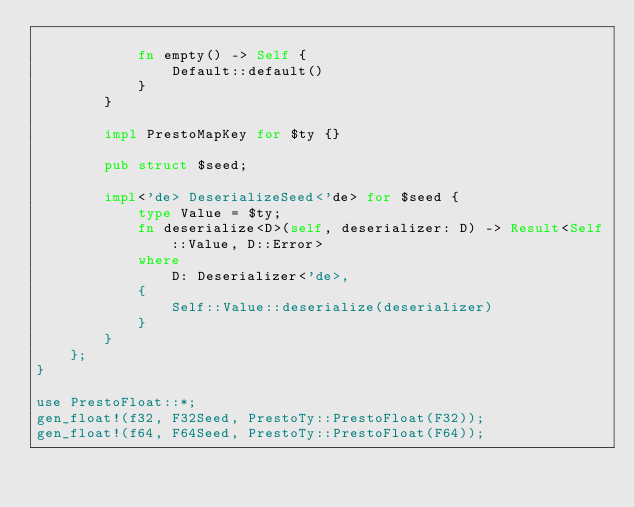Convert code to text. <code><loc_0><loc_0><loc_500><loc_500><_Rust_>
            fn empty() -> Self {
                Default::default()
            }
        }

        impl PrestoMapKey for $ty {}

        pub struct $seed;

        impl<'de> DeserializeSeed<'de> for $seed {
            type Value = $ty;
            fn deserialize<D>(self, deserializer: D) -> Result<Self::Value, D::Error>
            where
                D: Deserializer<'de>,
            {
                Self::Value::deserialize(deserializer)
            }
        }
    };
}

use PrestoFloat::*;
gen_float!(f32, F32Seed, PrestoTy::PrestoFloat(F32));
gen_float!(f64, F64Seed, PrestoTy::PrestoFloat(F64));
</code> 